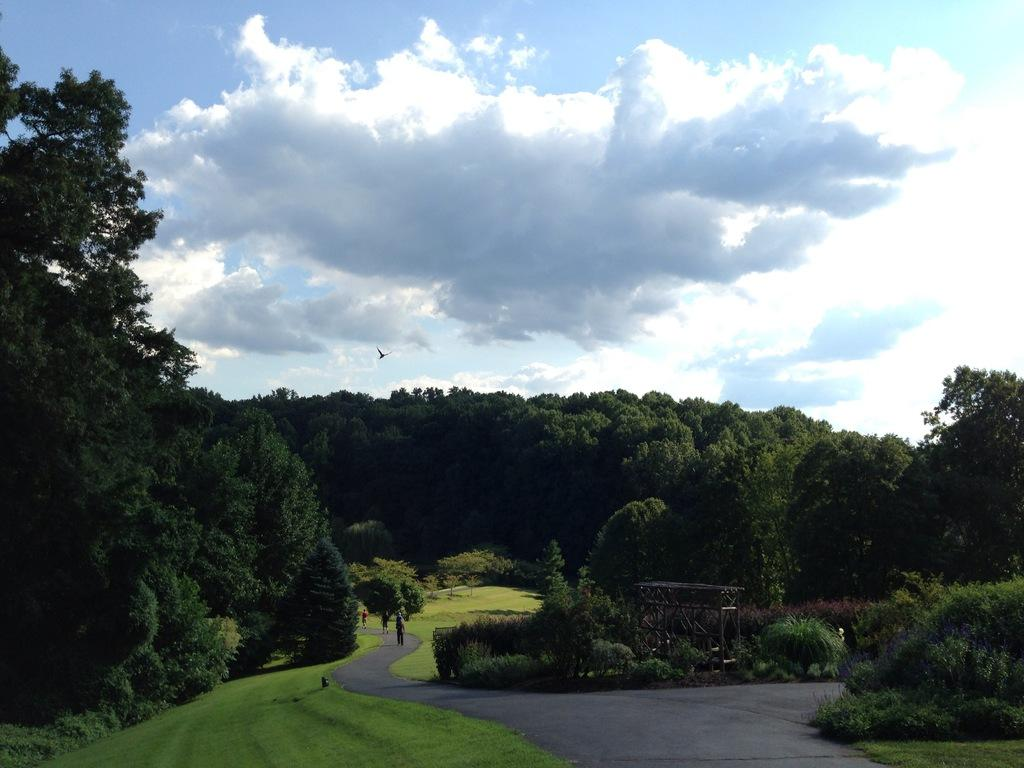What type of vegetation can be seen in the image? There are trees and plants in the image. What is the setting of the image? The image features people on the road. What type of apple can be seen growing on the trees in the image? There are no apples present in the image; the trees are not specified as fruit-bearing trees. 